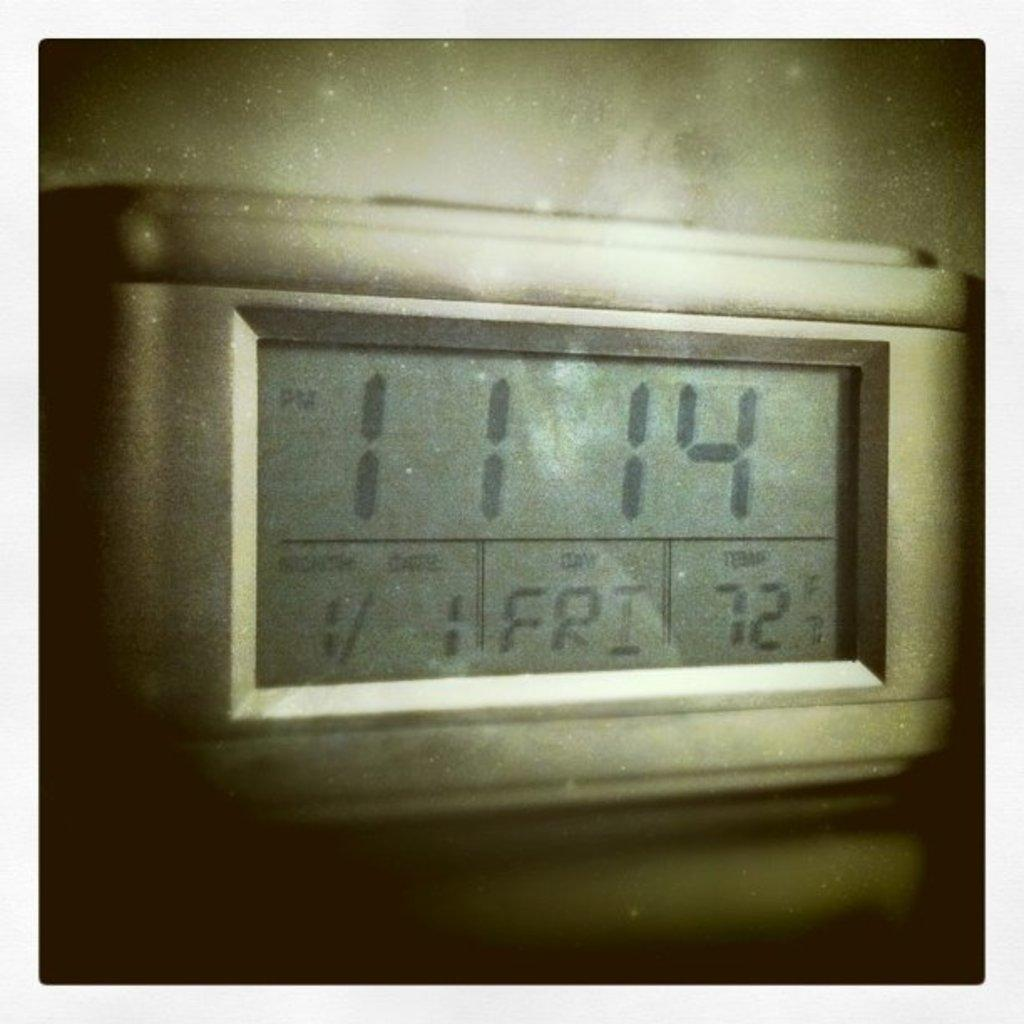<image>
Present a compact description of the photo's key features. a devise read the time as 11:14 as well as the date and temperature 